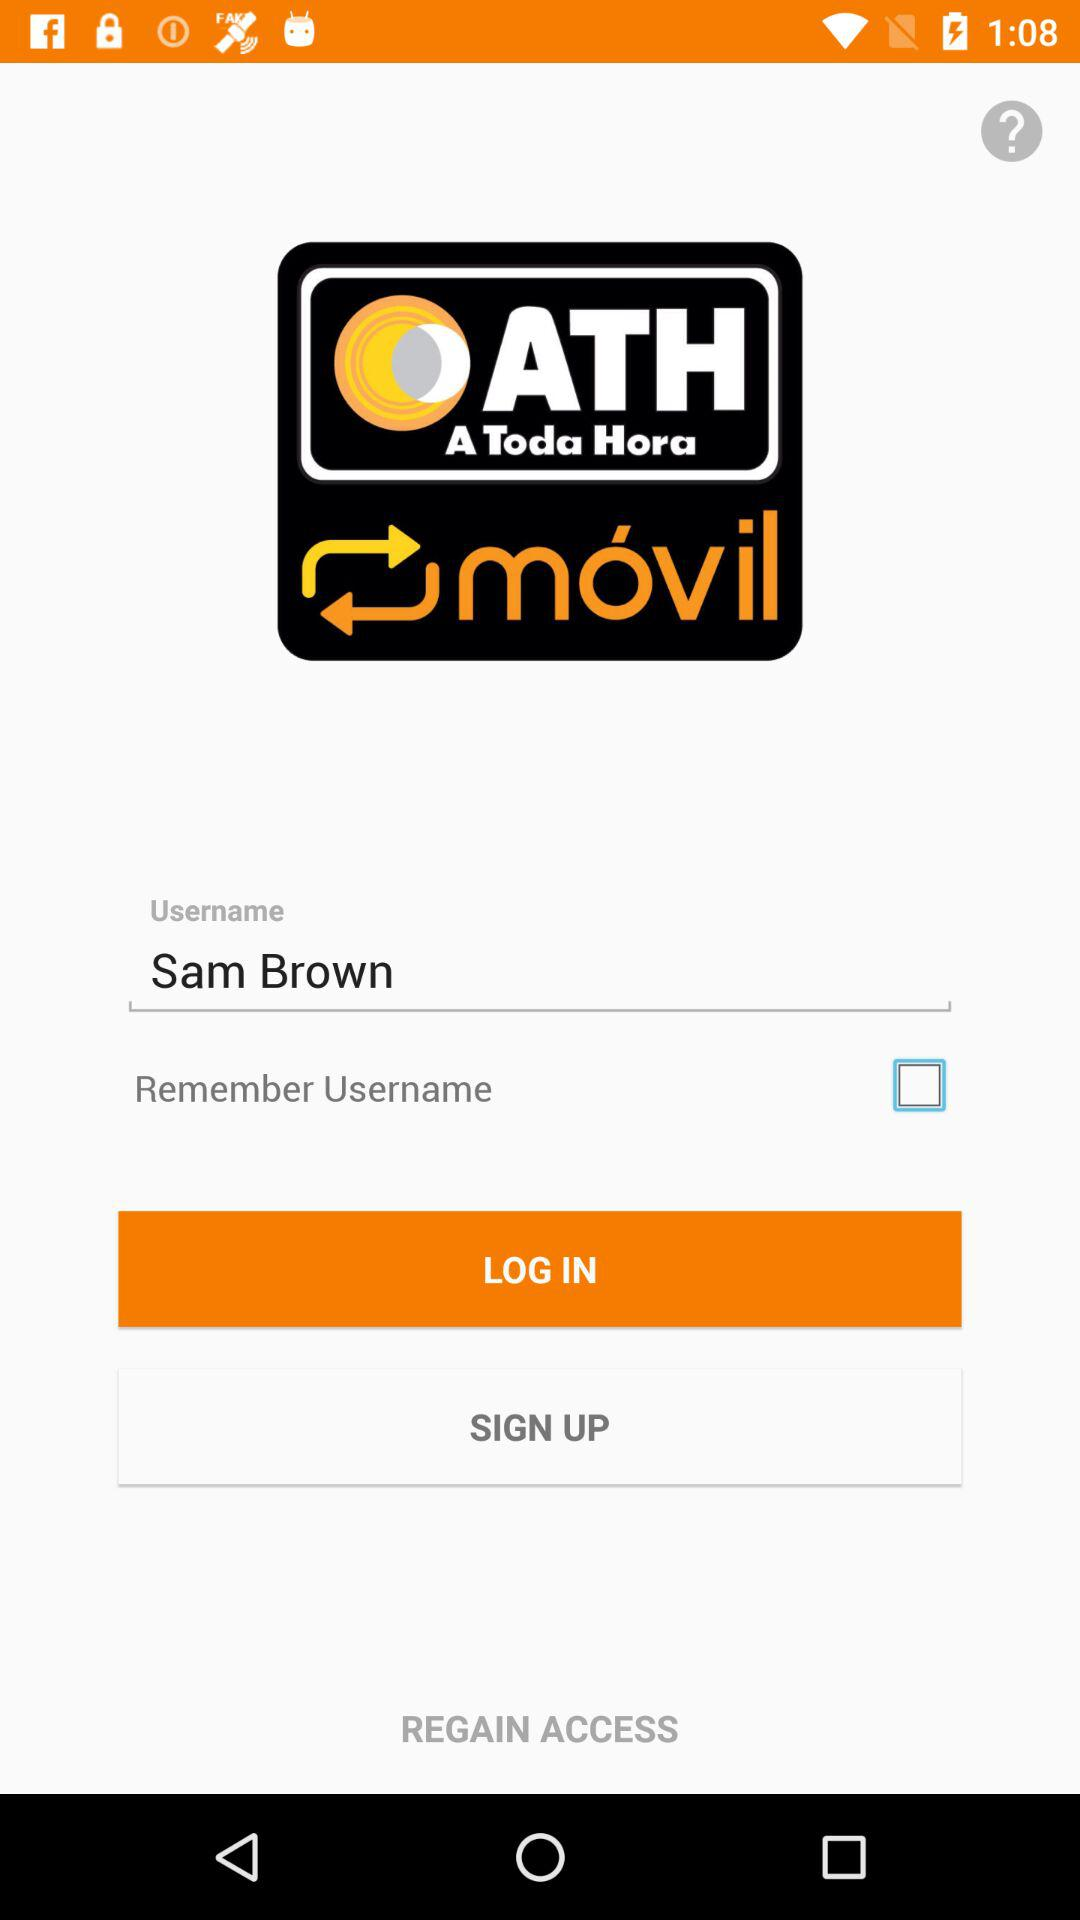What is required to log in? To log in, a username is required. 